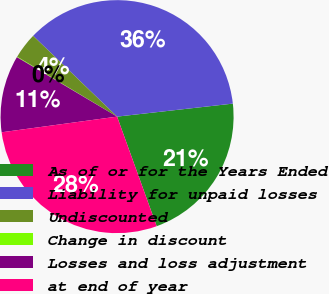Convert chart to OTSL. <chart><loc_0><loc_0><loc_500><loc_500><pie_chart><fcel>As of or for the Years Ended<fcel>Liability for unpaid losses<fcel>Undiscounted<fcel>Change in discount<fcel>Losses and loss adjustment<fcel>at end of year<nl><fcel>21.26%<fcel>36.02%<fcel>3.6%<fcel>0.07%<fcel>10.67%<fcel>28.37%<nl></chart> 